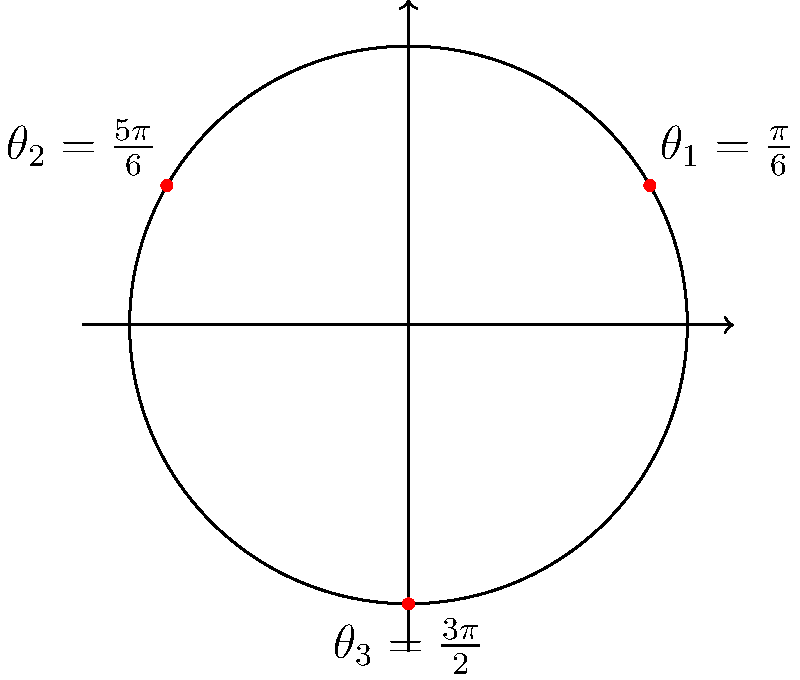As an immigration officer, you're tasked with optimizing the placement of three surveillance cameras along a circular border perimeter. The cameras are positioned at angles $\theta_1=\frac{\pi}{6}$, $\theta_2=\frac{5\pi}{6}$, and $\theta_3=\frac{3\pi}{2}$ radians, as shown in the diagram. What is the sum of the polar coordinate r-values for these three camera positions, given that the perimeter has a radius of 5 km? To solve this problem, we need to follow these steps:

1) Recall the formula for r in polar coordinates: $r = \text{radius}$

2) In this case, the radius is constant at 5 km for all points on the perimeter.

3) For each camera position:
   - Camera 1: $r_1 = 5$ km
   - Camera 2: $r_2 = 5$ km
   - Camera 3: $r_3 = 5$ km

4) Sum the r-values:
   $\text{Total} = r_1 + r_2 + r_3 = 5 + 5 + 5 = 15$ km

This problem demonstrates how polar coordinates can be used in real-world border surveillance scenarios. The constant r-value reflects the circular nature of the perimeter, while the θ values determine the exact positions of the cameras along this perimeter.
Answer: 15 km 